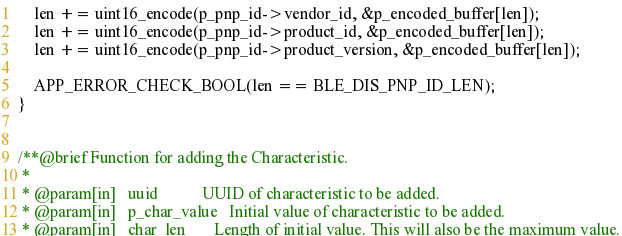<code> <loc_0><loc_0><loc_500><loc_500><_C_>    len += uint16_encode(p_pnp_id->vendor_id, &p_encoded_buffer[len]);
    len += uint16_encode(p_pnp_id->product_id, &p_encoded_buffer[len]);
    len += uint16_encode(p_pnp_id->product_version, &p_encoded_buffer[len]);

    APP_ERROR_CHECK_BOOL(len == BLE_DIS_PNP_ID_LEN);
}


/**@brief Function for adding the Characteristic.
 *
 * @param[in]   uuid           UUID of characteristic to be added.
 * @param[in]   p_char_value   Initial value of characteristic to be added.
 * @param[in]   char_len       Length of initial value. This will also be the maximum value.</code> 